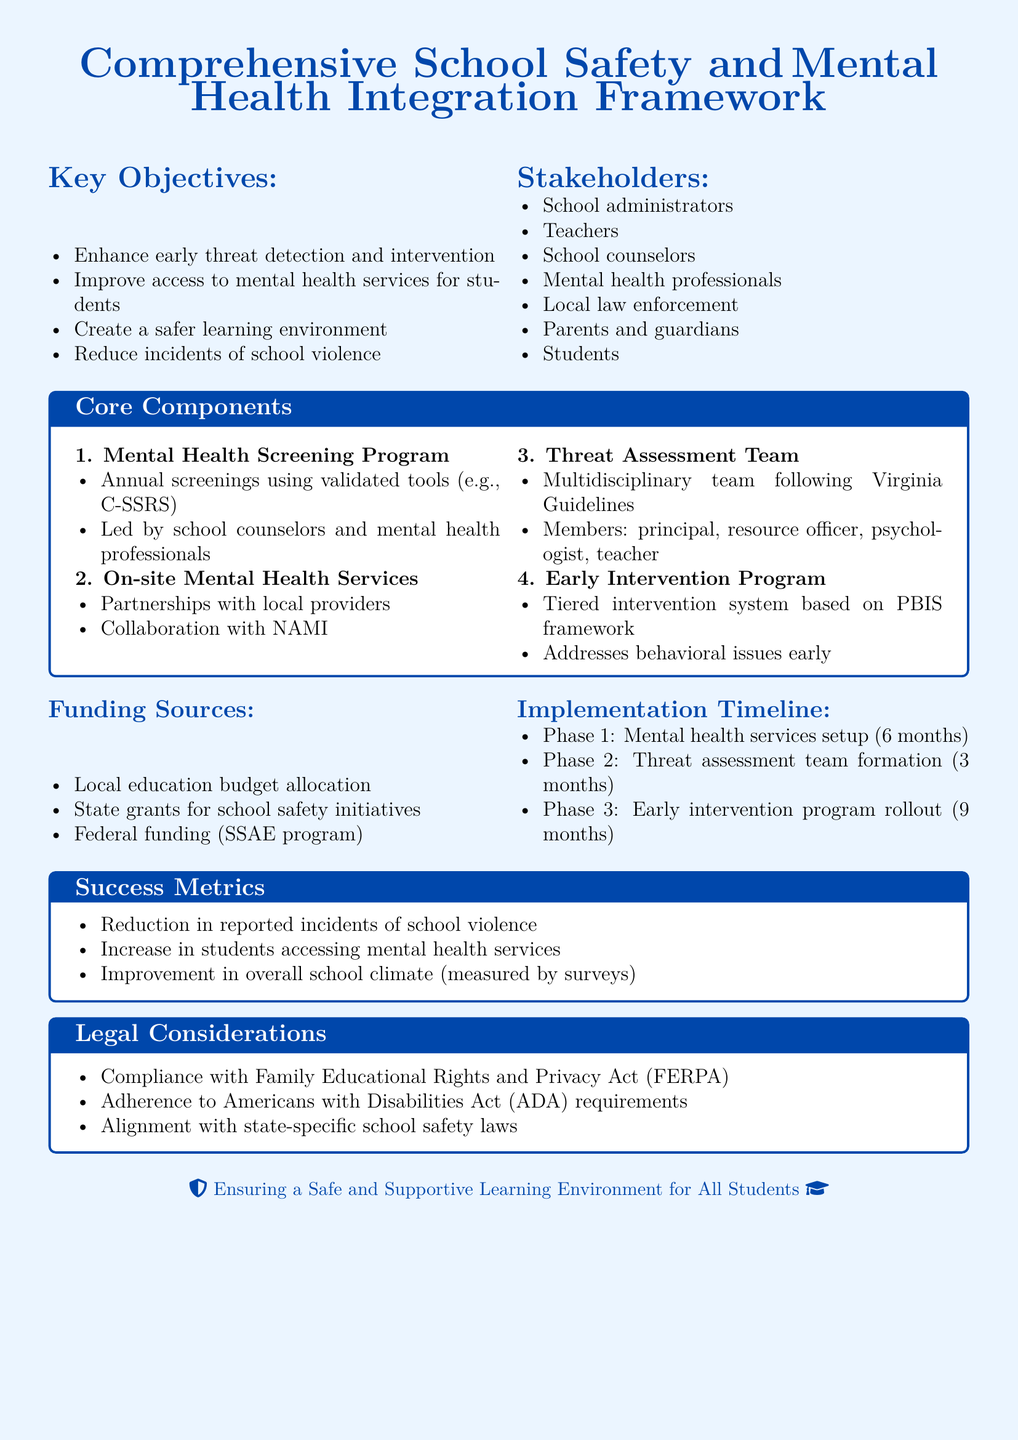What are the key objectives of the policy framework? The key objectives are listed in the document as enhancing early threat detection, improving access to mental health services, creating a safer learning environment, and reducing incidents of school violence.
Answer: Enhance early threat detection and intervention, Improve access to mental health services for students, Create a safer learning environment, Reduce incidents of school violence Who are the stakeholders involved in the program? The stakeholders are enumerated in the document and include various members of the school community and local agencies.
Answer: School administrators, Teachers, School counselors, Mental health professionals, Local law enforcement, Parents and guardians, Students What is the funding source for the programs? The document specifies the funding sources available for school safety initiatives.
Answer: Local education budget allocation, State grants for school safety initiatives, Federal funding (SSAE program) What is the duration for Phase 1 of the implementation timeline? The document outlines the implementation phases and their respective durations.
Answer: 6 months What is one success metric mentioned in the document? The success metrics measure the effectiveness of the policies based on specific outcomes.
Answer: Reduction in reported incidents of school violence What is the composition of the Threat Assessment Team? The document details the members of the team responsible for threat assessments in schools.
Answer: principal, resource officer, psychologist, teacher Which framework does the Early Intervention Program follow? The document refers to a particular framework guiding the early intervention strategies.
Answer: PBIS framework What is the legal act mentioned concerning educational privacy? The document includes legal considerations essential for implementing the proposed policy.
Answer: Family Educational Rights and Privacy Act (FERPA) 